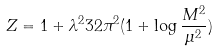Convert formula to latex. <formula><loc_0><loc_0><loc_500><loc_500>Z = 1 + \lambda ^ { 2 } { 3 2 \pi ^ { 2 } } ( 1 + \log \frac { M ^ { 2 } } { \mu ^ { 2 } } )</formula> 